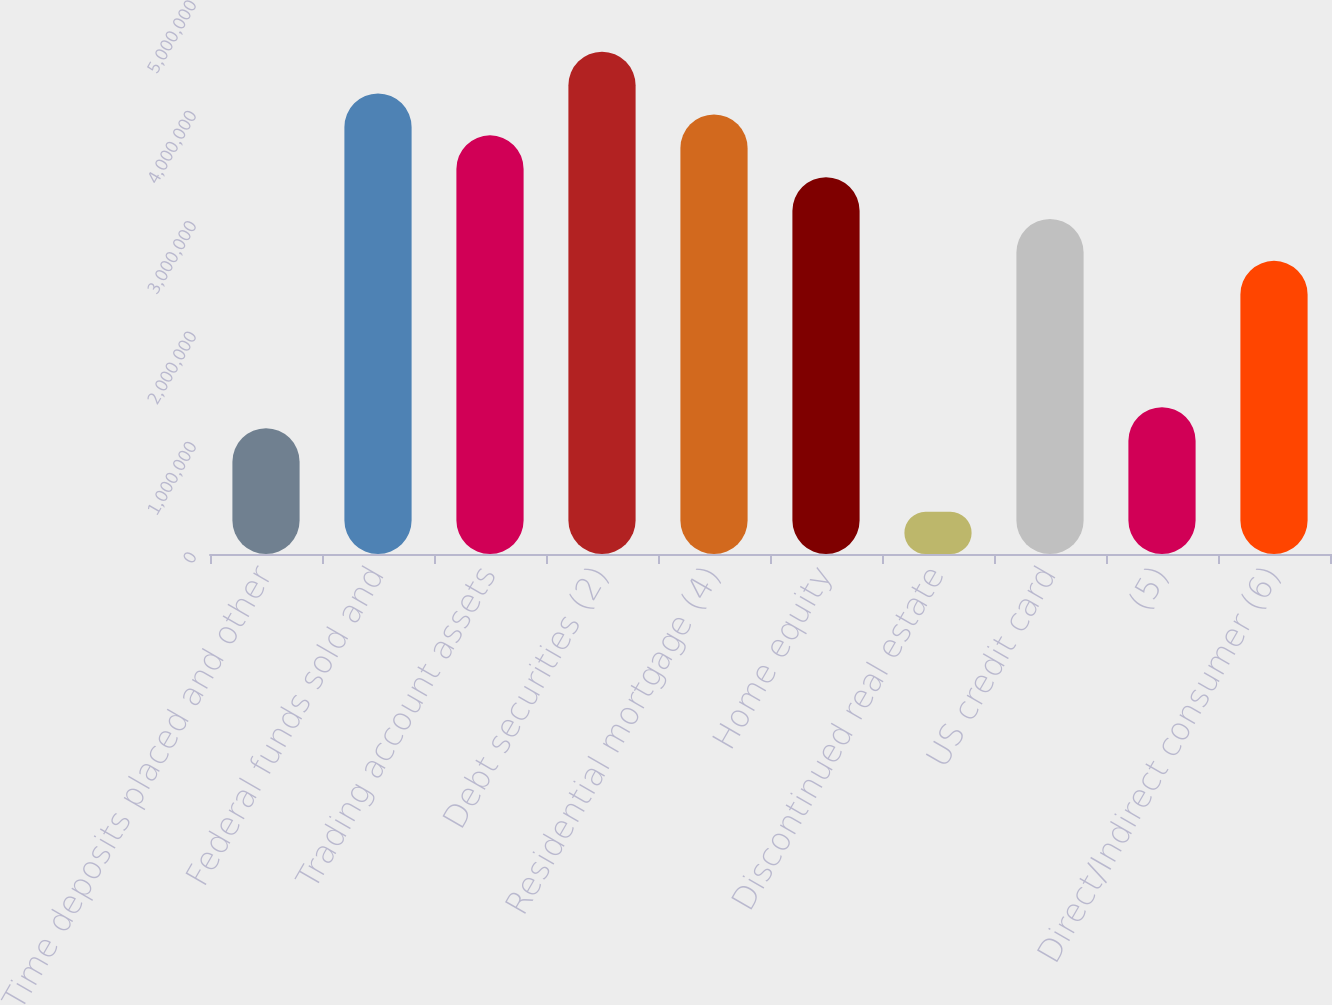Convert chart. <chart><loc_0><loc_0><loc_500><loc_500><bar_chart><fcel>Time deposits placed and other<fcel>Federal funds sold and<fcel>Trading account assets<fcel>Debt securities (2)<fcel>Residential mortgage (4)<fcel>Home equity<fcel>Discontinued real estate<fcel>US credit card<fcel>(5)<fcel>Direct/Indirect consumer (6)<nl><fcel>1.13971e+06<fcel>4.17115e+06<fcel>3.79222e+06<fcel>4.55008e+06<fcel>3.98168e+06<fcel>3.41329e+06<fcel>381856<fcel>3.03436e+06<fcel>1.32918e+06<fcel>2.65543e+06<nl></chart> 